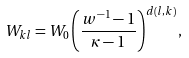<formula> <loc_0><loc_0><loc_500><loc_500>W _ { k l } = W _ { 0 } \left ( \frac { w ^ { - 1 } - 1 } { \kappa - 1 } \right ) ^ { d ( l , k ) } ,</formula> 